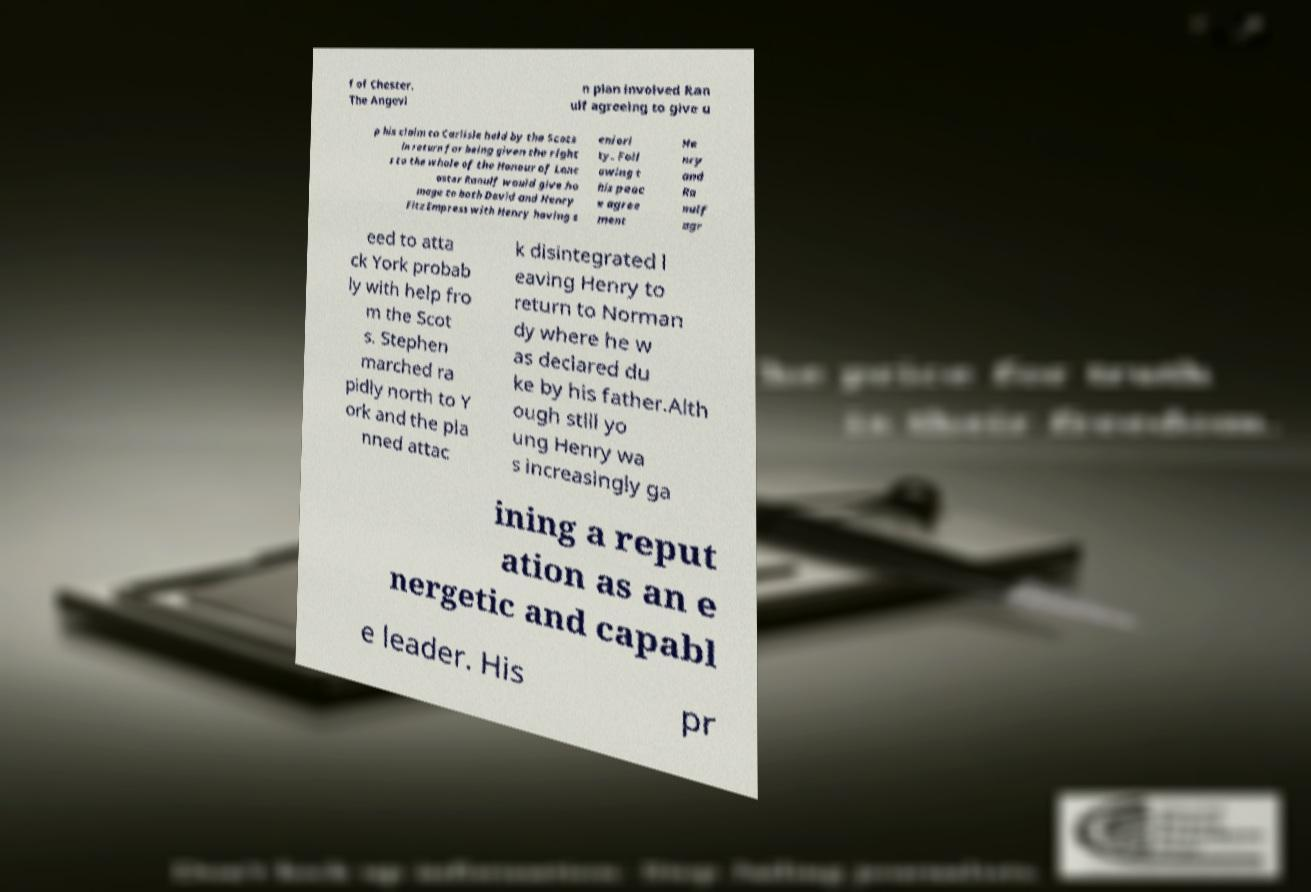Can you accurately transcribe the text from the provided image for me? f of Chester. The Angevi n plan involved Ran ulf agreeing to give u p his claim to Carlisle held by the Scots in return for being given the right s to the whole of the Honour of Lanc aster Ranulf would give ho mage to both David and Henry FitzEmpress with Henry having s eniori ty. Foll owing t his peac e agree ment He nry and Ra nulf agr eed to atta ck York probab ly with help fro m the Scot s. Stephen marched ra pidly north to Y ork and the pla nned attac k disintegrated l eaving Henry to return to Norman dy where he w as declared du ke by his father.Alth ough still yo ung Henry wa s increasingly ga ining a reput ation as an e nergetic and capabl e leader. His pr 